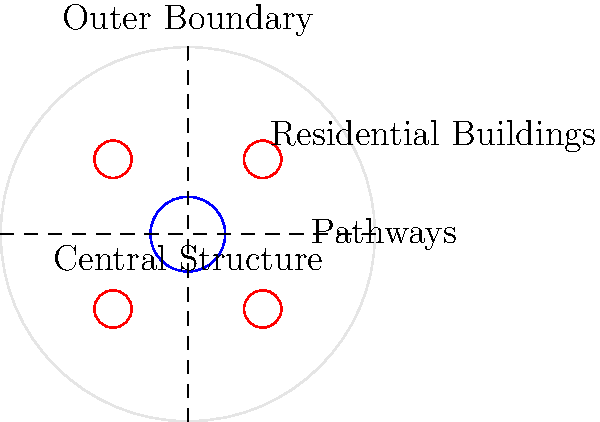Based on the diagram of a traditional Xindi settlement, what geometric shape best describes the overall layout, and how does this structure reflect Xindi cultural values? To answer this question, let's analyze the diagram step-by-step:

1. Overall shape: The settlement is enclosed in a circular boundary, representing the overall layout.

2. Central structure: There is a prominent circular structure at the center of the settlement.

3. Residential buildings: Four smaller circular structures are positioned symmetrically around the central structure, likely representing residential or communal buildings.

4. Pathways: Two perpendicular pathways intersect at the center, dividing the settlement into four equal quadrants.

5. Symmetry: The layout exhibits perfect radial symmetry, with all elements balanced around the central point.

This circular layout with radial symmetry reflects several Xindi cultural values:

a) Unity: The circular shape symbolizes unity and inclusiveness within the community.

b) Centrality: The prominent central structure suggests the importance of a shared focal point, possibly for governance or spiritual purposes.

c) Equality: The symmetrical arrangement of residential buildings implies a sense of equality among community members.

d) Balance: The overall design demonstrates a balance between communal (central) and individual (residential) spaces.

e) Connectivity: The intersecting pathways facilitate easy movement and communication within the settlement.

The circular layout with its radial symmetry efficiently combines these cultural values into a functional settlement design.
Answer: Circular; reflects unity, centrality, equality, balance, and connectivity 